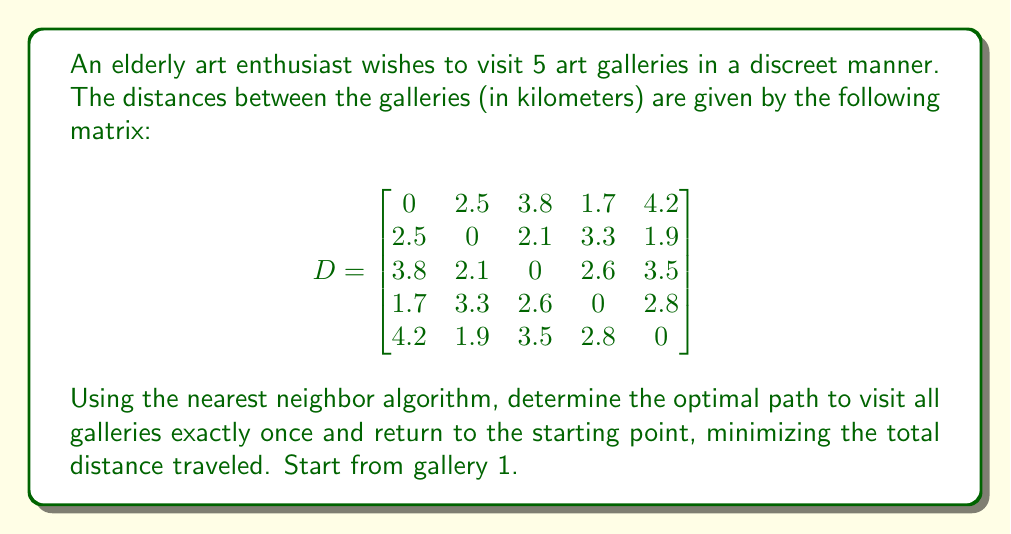Show me your answer to this math problem. To solve this problem using the nearest neighbor algorithm, we'll follow these steps:

1. Start at gallery 1.
2. Find the nearest unvisited gallery.
3. Move to that gallery and mark it as visited.
4. Repeat steps 2-3 until all galleries are visited.
5. Return to the starting gallery.

Let's go through the process:

1. Start at gallery 1.

2. From gallery 1, find the nearest unvisited gallery:
   Gallery 2: 2.5 km
   Gallery 3: 3.8 km
   Gallery 4: 1.7 km
   Gallery 5: 4.2 km
   The nearest is gallery 4 at 1.7 km.

3. Move to gallery 4 and mark it as visited.

4. From gallery 4, find the nearest unvisited gallery:
   Gallery 2: 3.3 km
   Gallery 3: 2.6 km
   Gallery 5: 2.8 km
   The nearest is gallery 3 at 2.6 km.

5. Move to gallery 3 and mark it as visited.

6. From gallery 3, find the nearest unvisited gallery:
   Gallery 2: 2.1 km
   Gallery 5: 3.5 km
   The nearest is gallery 2 at 2.1 km.

7. Move to gallery 2 and mark it as visited.

8. From gallery 2, the only unvisited gallery is 5, at 1.9 km.

9. Move to gallery 5 and mark it as visited.

10. Return to the starting point (gallery 1) from gallery 5: 4.2 km.

The total distance traveled is:
$1.7 + 2.6 + 2.1 + 1.9 + 4.2 = 12.5$ km

The optimal path is: 1 → 4 → 3 → 2 → 5 → 1
Answer: The optimal path using the nearest neighbor algorithm is 1 → 4 → 3 → 2 → 5 → 1, with a total distance of 12.5 km. 